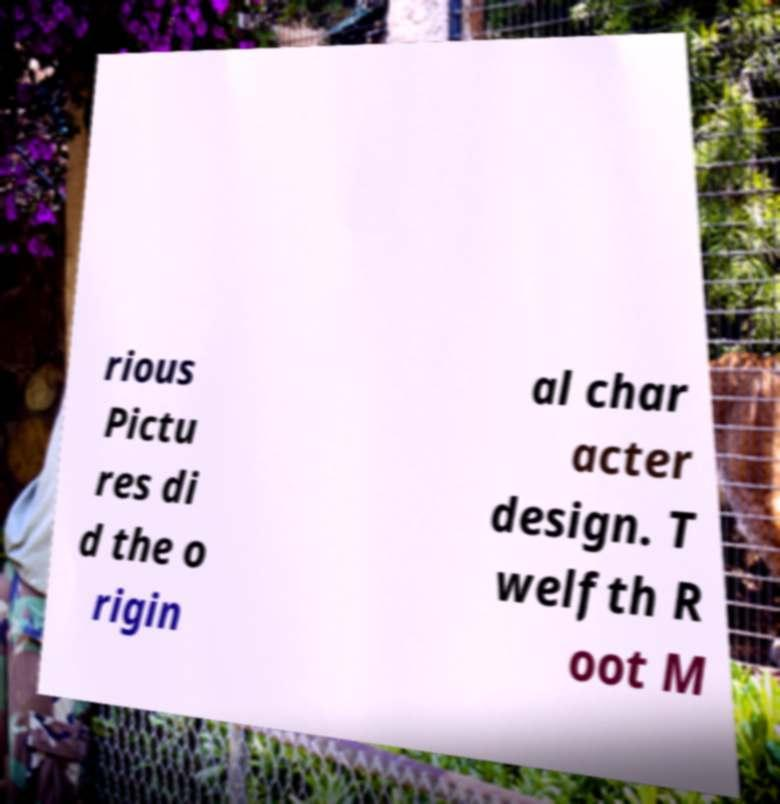Could you assist in decoding the text presented in this image and type it out clearly? rious Pictu res di d the o rigin al char acter design. T welfth R oot M 